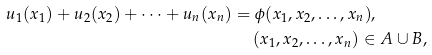Convert formula to latex. <formula><loc_0><loc_0><loc_500><loc_500>u _ { 1 } ( x _ { 1 } ) + u _ { 2 } ( x _ { 2 } ) + \cdots + u _ { n } ( x _ { n } ) & = \phi ( x _ { 1 } , x _ { 2 } , \dots , x _ { n } ) , \\ & \quad \ ( x _ { 1 } , x _ { 2 } , \dots , x _ { n } ) \in A \cup B ,</formula> 